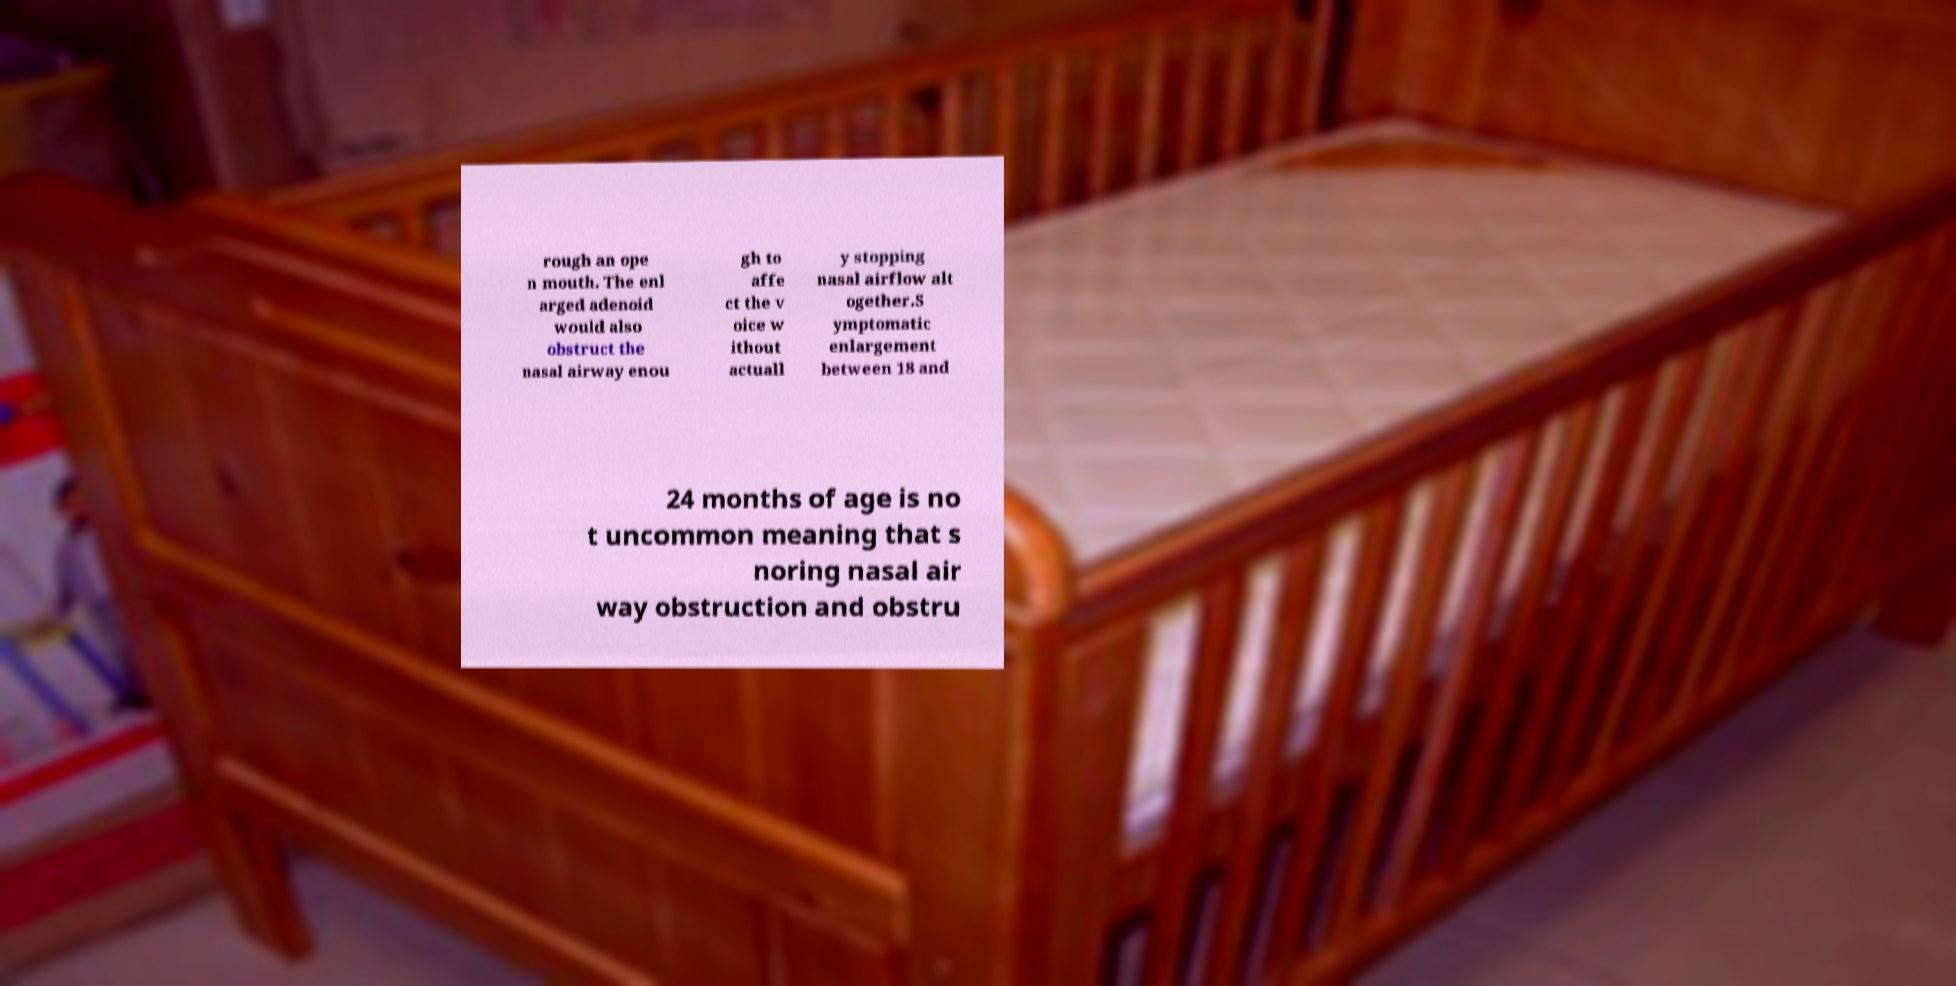Please read and relay the text visible in this image. What does it say? rough an ope n mouth. The enl arged adenoid would also obstruct the nasal airway enou gh to affe ct the v oice w ithout actuall y stopping nasal airflow alt ogether.S ymptomatic enlargement between 18 and 24 months of age is no t uncommon meaning that s noring nasal air way obstruction and obstru 